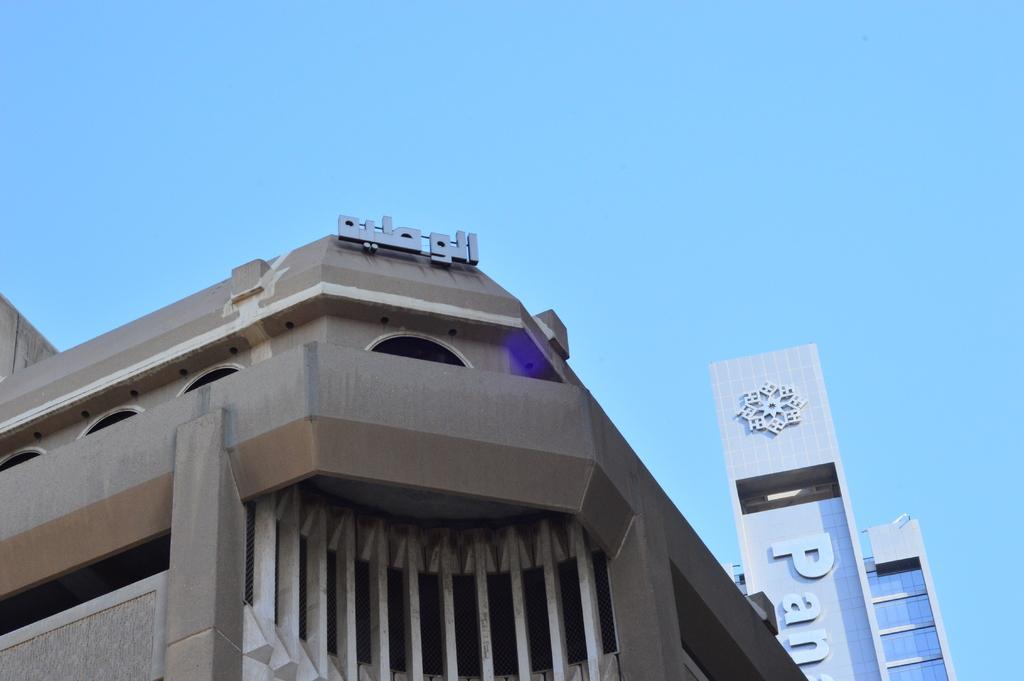Could you give a brief overview of what you see in this image? In the picture I can see buildings. I can also see some names on buildings. In the background I can see the sky. 